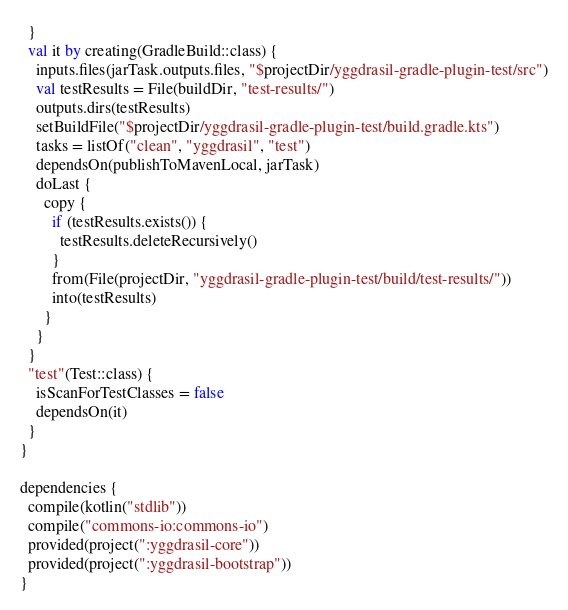Convert code to text. <code><loc_0><loc_0><loc_500><loc_500><_Kotlin_>  }
  val it by creating(GradleBuild::class) {
    inputs.files(jarTask.outputs.files, "$projectDir/yggdrasil-gradle-plugin-test/src")
    val testResults = File(buildDir, "test-results/")
    outputs.dirs(testResults)
    setBuildFile("$projectDir/yggdrasil-gradle-plugin-test/build.gradle.kts")
    tasks = listOf("clean", "yggdrasil", "test")
    dependsOn(publishToMavenLocal, jarTask)
    doLast {
      copy {
        if (testResults.exists()) {
          testResults.deleteRecursively()
        }
        from(File(projectDir, "yggdrasil-gradle-plugin-test/build/test-results/"))
        into(testResults)
      }
    }
  }
  "test"(Test::class) {
    isScanForTestClasses = false
    dependsOn(it)
  }
}

dependencies {
  compile(kotlin("stdlib"))
  compile("commons-io:commons-io")
  provided(project(":yggdrasil-core"))
  provided(project(":yggdrasil-bootstrap"))
}
</code> 